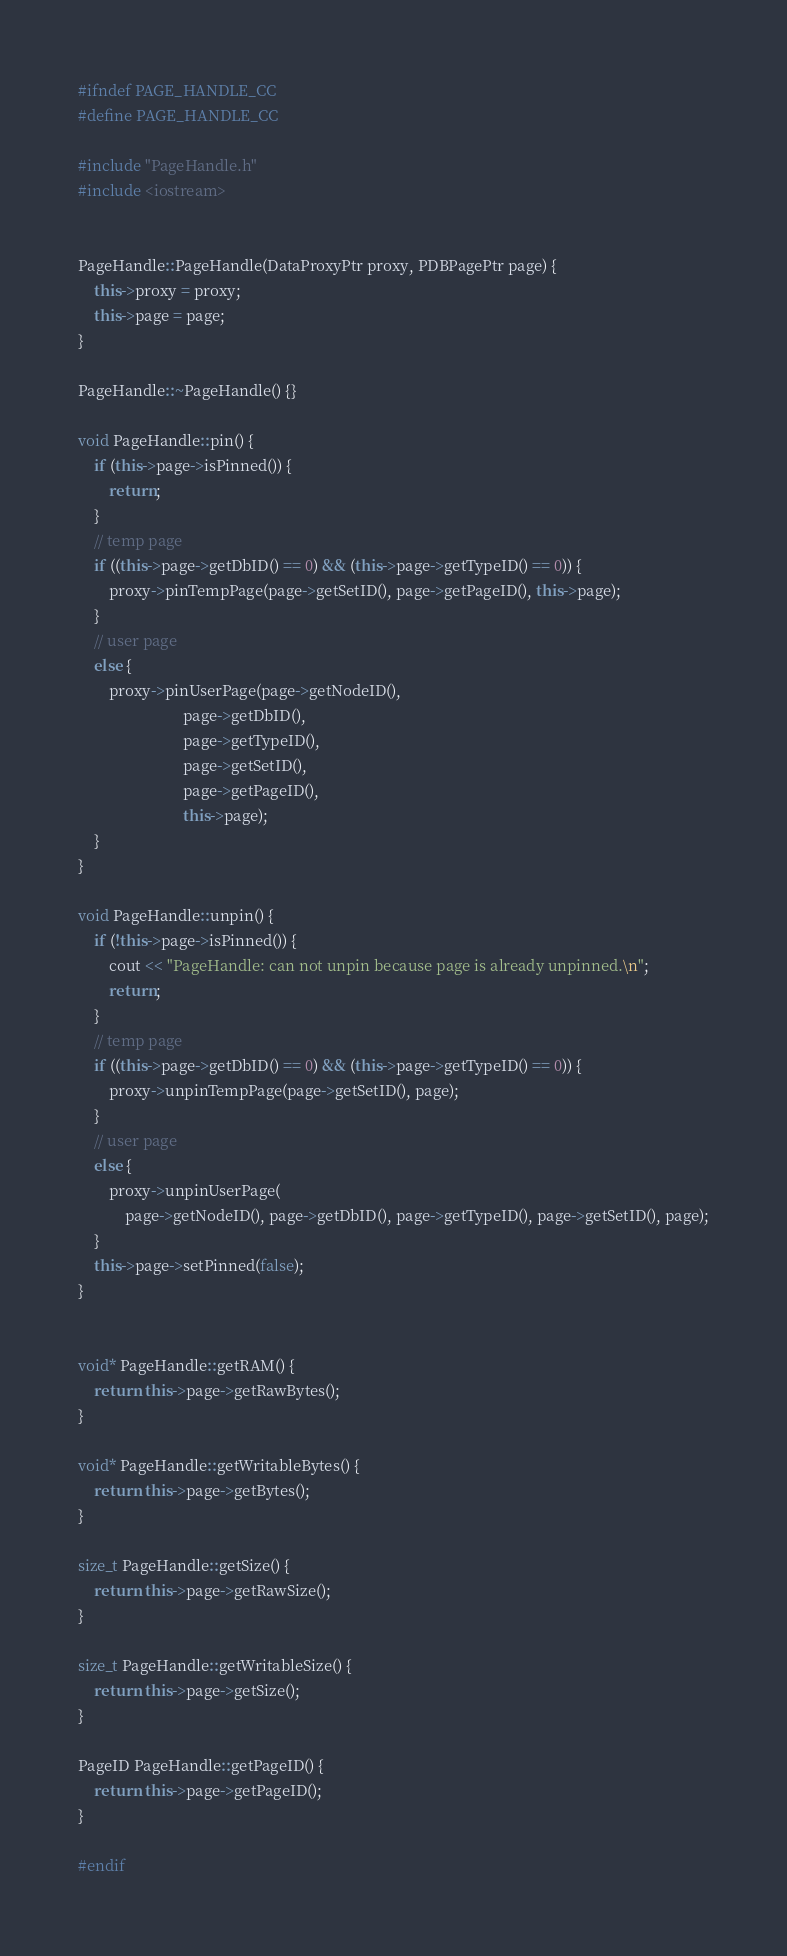<code> <loc_0><loc_0><loc_500><loc_500><_C++_>
#ifndef PAGE_HANDLE_CC
#define PAGE_HANDLE_CC

#include "PageHandle.h"
#include <iostream>


PageHandle::PageHandle(DataProxyPtr proxy, PDBPagePtr page) {
    this->proxy = proxy;
    this->page = page;
}

PageHandle::~PageHandle() {}

void PageHandle::pin() {
    if (this->page->isPinned()) {
        return;
    }
    // temp page
    if ((this->page->getDbID() == 0) && (this->page->getTypeID() == 0)) {
        proxy->pinTempPage(page->getSetID(), page->getPageID(), this->page);
    }
    // user page
    else {
        proxy->pinUserPage(page->getNodeID(),
                           page->getDbID(),
                           page->getTypeID(),
                           page->getSetID(),
                           page->getPageID(),
                           this->page);
    }
}

void PageHandle::unpin() {
    if (!this->page->isPinned()) {
        cout << "PageHandle: can not unpin because page is already unpinned.\n";
        return;
    }
    // temp page
    if ((this->page->getDbID() == 0) && (this->page->getTypeID() == 0)) {
        proxy->unpinTempPage(page->getSetID(), page);
    }
    // user page
    else {
        proxy->unpinUserPage(
            page->getNodeID(), page->getDbID(), page->getTypeID(), page->getSetID(), page);
    }
    this->page->setPinned(false);
}


void* PageHandle::getRAM() {
    return this->page->getRawBytes();
}

void* PageHandle::getWritableBytes() {
    return this->page->getBytes();
}

size_t PageHandle::getSize() {
    return this->page->getRawSize();
}

size_t PageHandle::getWritableSize() {
    return this->page->getSize();
}

PageID PageHandle::getPageID() {
    return this->page->getPageID();
}

#endif
</code> 